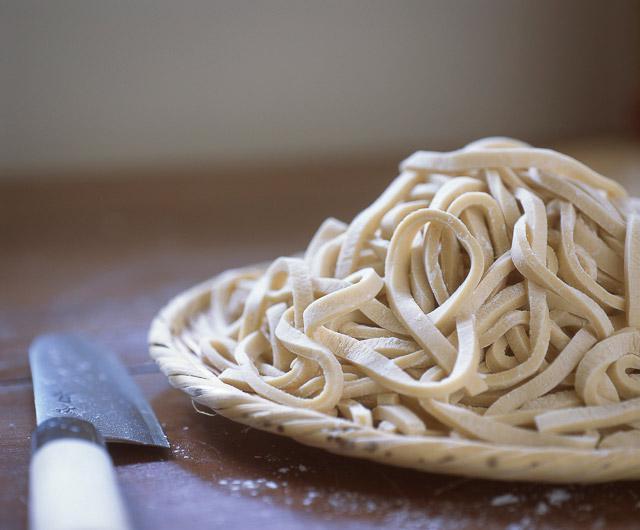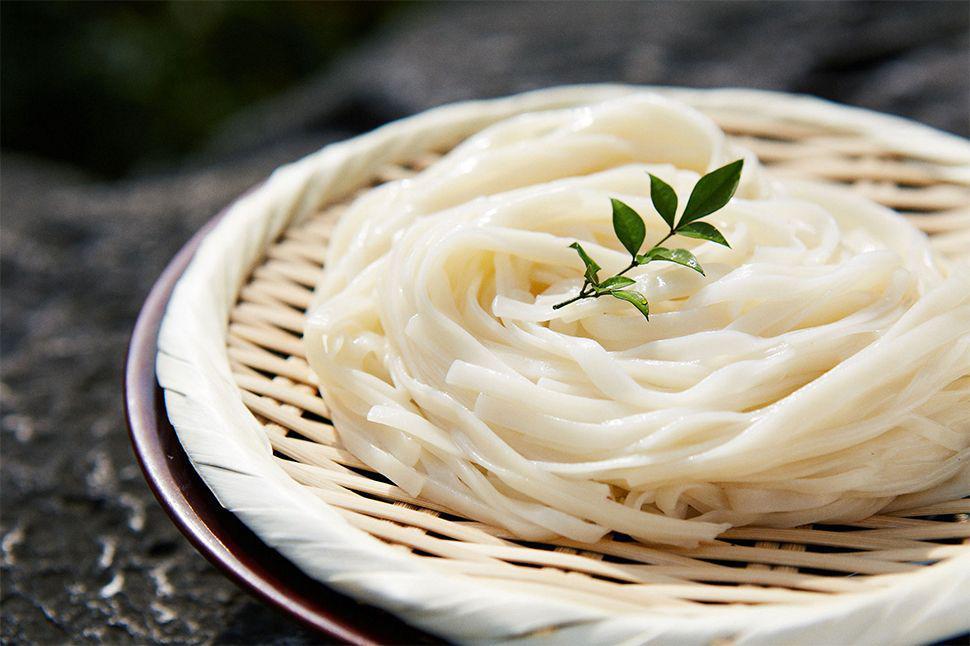The first image is the image on the left, the second image is the image on the right. Analyze the images presented: Is the assertion "The pasta in the image on the left is sitting atop a dusting of flour." valid? Answer yes or no. No. 